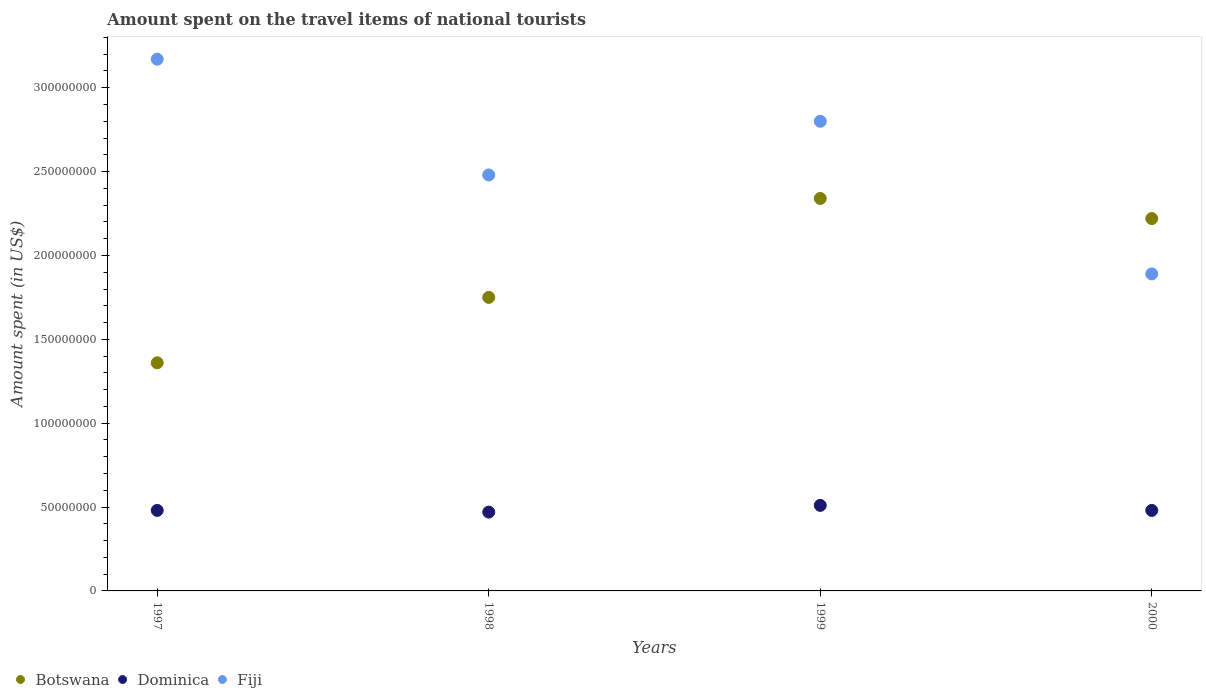Is the number of dotlines equal to the number of legend labels?
Your answer should be compact. Yes. What is the amount spent on the travel items of national tourists in Fiji in 1997?
Your answer should be very brief. 3.17e+08. Across all years, what is the maximum amount spent on the travel items of national tourists in Dominica?
Make the answer very short. 5.10e+07. Across all years, what is the minimum amount spent on the travel items of national tourists in Dominica?
Offer a very short reply. 4.70e+07. What is the total amount spent on the travel items of national tourists in Fiji in the graph?
Your answer should be compact. 1.03e+09. What is the difference between the amount spent on the travel items of national tourists in Fiji in 1998 and that in 1999?
Provide a succinct answer. -3.20e+07. What is the difference between the amount spent on the travel items of national tourists in Fiji in 1997 and the amount spent on the travel items of national tourists in Botswana in 1999?
Offer a terse response. 8.30e+07. What is the average amount spent on the travel items of national tourists in Botswana per year?
Provide a succinct answer. 1.92e+08. In the year 2000, what is the difference between the amount spent on the travel items of national tourists in Dominica and amount spent on the travel items of national tourists in Fiji?
Provide a succinct answer. -1.41e+08. What is the ratio of the amount spent on the travel items of national tourists in Botswana in 1999 to that in 2000?
Provide a short and direct response. 1.05. Is the difference between the amount spent on the travel items of national tourists in Dominica in 1998 and 1999 greater than the difference between the amount spent on the travel items of national tourists in Fiji in 1998 and 1999?
Your response must be concise. Yes. What is the difference between the highest and the lowest amount spent on the travel items of national tourists in Dominica?
Make the answer very short. 4.00e+06. Is the sum of the amount spent on the travel items of national tourists in Fiji in 1998 and 2000 greater than the maximum amount spent on the travel items of national tourists in Botswana across all years?
Offer a very short reply. Yes. Is the amount spent on the travel items of national tourists in Botswana strictly greater than the amount spent on the travel items of national tourists in Dominica over the years?
Make the answer very short. Yes. What is the difference between two consecutive major ticks on the Y-axis?
Give a very brief answer. 5.00e+07. Does the graph contain any zero values?
Keep it short and to the point. No. Does the graph contain grids?
Offer a terse response. No. How many legend labels are there?
Provide a succinct answer. 3. What is the title of the graph?
Your response must be concise. Amount spent on the travel items of national tourists. What is the label or title of the X-axis?
Your response must be concise. Years. What is the label or title of the Y-axis?
Make the answer very short. Amount spent (in US$). What is the Amount spent (in US$) of Botswana in 1997?
Provide a short and direct response. 1.36e+08. What is the Amount spent (in US$) of Dominica in 1997?
Give a very brief answer. 4.80e+07. What is the Amount spent (in US$) of Fiji in 1997?
Make the answer very short. 3.17e+08. What is the Amount spent (in US$) of Botswana in 1998?
Make the answer very short. 1.75e+08. What is the Amount spent (in US$) in Dominica in 1998?
Offer a very short reply. 4.70e+07. What is the Amount spent (in US$) of Fiji in 1998?
Ensure brevity in your answer.  2.48e+08. What is the Amount spent (in US$) of Botswana in 1999?
Ensure brevity in your answer.  2.34e+08. What is the Amount spent (in US$) in Dominica in 1999?
Your response must be concise. 5.10e+07. What is the Amount spent (in US$) in Fiji in 1999?
Ensure brevity in your answer.  2.80e+08. What is the Amount spent (in US$) in Botswana in 2000?
Your response must be concise. 2.22e+08. What is the Amount spent (in US$) in Dominica in 2000?
Give a very brief answer. 4.80e+07. What is the Amount spent (in US$) in Fiji in 2000?
Give a very brief answer. 1.89e+08. Across all years, what is the maximum Amount spent (in US$) of Botswana?
Make the answer very short. 2.34e+08. Across all years, what is the maximum Amount spent (in US$) in Dominica?
Make the answer very short. 5.10e+07. Across all years, what is the maximum Amount spent (in US$) in Fiji?
Your response must be concise. 3.17e+08. Across all years, what is the minimum Amount spent (in US$) in Botswana?
Keep it short and to the point. 1.36e+08. Across all years, what is the minimum Amount spent (in US$) in Dominica?
Offer a very short reply. 4.70e+07. Across all years, what is the minimum Amount spent (in US$) of Fiji?
Make the answer very short. 1.89e+08. What is the total Amount spent (in US$) in Botswana in the graph?
Offer a very short reply. 7.67e+08. What is the total Amount spent (in US$) of Dominica in the graph?
Offer a terse response. 1.94e+08. What is the total Amount spent (in US$) of Fiji in the graph?
Provide a short and direct response. 1.03e+09. What is the difference between the Amount spent (in US$) in Botswana in 1997 and that in 1998?
Your answer should be compact. -3.90e+07. What is the difference between the Amount spent (in US$) in Dominica in 1997 and that in 1998?
Provide a short and direct response. 1.00e+06. What is the difference between the Amount spent (in US$) in Fiji in 1997 and that in 1998?
Keep it short and to the point. 6.90e+07. What is the difference between the Amount spent (in US$) of Botswana in 1997 and that in 1999?
Provide a succinct answer. -9.80e+07. What is the difference between the Amount spent (in US$) in Dominica in 1997 and that in 1999?
Your answer should be compact. -3.00e+06. What is the difference between the Amount spent (in US$) in Fiji in 1997 and that in 1999?
Your answer should be compact. 3.70e+07. What is the difference between the Amount spent (in US$) of Botswana in 1997 and that in 2000?
Provide a short and direct response. -8.60e+07. What is the difference between the Amount spent (in US$) in Dominica in 1997 and that in 2000?
Give a very brief answer. 0. What is the difference between the Amount spent (in US$) in Fiji in 1997 and that in 2000?
Offer a terse response. 1.28e+08. What is the difference between the Amount spent (in US$) of Botswana in 1998 and that in 1999?
Your response must be concise. -5.90e+07. What is the difference between the Amount spent (in US$) in Dominica in 1998 and that in 1999?
Keep it short and to the point. -4.00e+06. What is the difference between the Amount spent (in US$) in Fiji in 1998 and that in 1999?
Your response must be concise. -3.20e+07. What is the difference between the Amount spent (in US$) in Botswana in 1998 and that in 2000?
Offer a terse response. -4.70e+07. What is the difference between the Amount spent (in US$) in Fiji in 1998 and that in 2000?
Provide a short and direct response. 5.90e+07. What is the difference between the Amount spent (in US$) of Botswana in 1999 and that in 2000?
Keep it short and to the point. 1.20e+07. What is the difference between the Amount spent (in US$) of Fiji in 1999 and that in 2000?
Make the answer very short. 9.10e+07. What is the difference between the Amount spent (in US$) of Botswana in 1997 and the Amount spent (in US$) of Dominica in 1998?
Make the answer very short. 8.90e+07. What is the difference between the Amount spent (in US$) of Botswana in 1997 and the Amount spent (in US$) of Fiji in 1998?
Offer a terse response. -1.12e+08. What is the difference between the Amount spent (in US$) in Dominica in 1997 and the Amount spent (in US$) in Fiji in 1998?
Ensure brevity in your answer.  -2.00e+08. What is the difference between the Amount spent (in US$) in Botswana in 1997 and the Amount spent (in US$) in Dominica in 1999?
Offer a very short reply. 8.50e+07. What is the difference between the Amount spent (in US$) in Botswana in 1997 and the Amount spent (in US$) in Fiji in 1999?
Make the answer very short. -1.44e+08. What is the difference between the Amount spent (in US$) in Dominica in 1997 and the Amount spent (in US$) in Fiji in 1999?
Provide a succinct answer. -2.32e+08. What is the difference between the Amount spent (in US$) of Botswana in 1997 and the Amount spent (in US$) of Dominica in 2000?
Keep it short and to the point. 8.80e+07. What is the difference between the Amount spent (in US$) of Botswana in 1997 and the Amount spent (in US$) of Fiji in 2000?
Offer a very short reply. -5.30e+07. What is the difference between the Amount spent (in US$) in Dominica in 1997 and the Amount spent (in US$) in Fiji in 2000?
Your answer should be very brief. -1.41e+08. What is the difference between the Amount spent (in US$) of Botswana in 1998 and the Amount spent (in US$) of Dominica in 1999?
Offer a terse response. 1.24e+08. What is the difference between the Amount spent (in US$) of Botswana in 1998 and the Amount spent (in US$) of Fiji in 1999?
Give a very brief answer. -1.05e+08. What is the difference between the Amount spent (in US$) of Dominica in 1998 and the Amount spent (in US$) of Fiji in 1999?
Offer a terse response. -2.33e+08. What is the difference between the Amount spent (in US$) in Botswana in 1998 and the Amount spent (in US$) in Dominica in 2000?
Ensure brevity in your answer.  1.27e+08. What is the difference between the Amount spent (in US$) in Botswana in 1998 and the Amount spent (in US$) in Fiji in 2000?
Offer a very short reply. -1.40e+07. What is the difference between the Amount spent (in US$) of Dominica in 1998 and the Amount spent (in US$) of Fiji in 2000?
Provide a short and direct response. -1.42e+08. What is the difference between the Amount spent (in US$) of Botswana in 1999 and the Amount spent (in US$) of Dominica in 2000?
Offer a very short reply. 1.86e+08. What is the difference between the Amount spent (in US$) in Botswana in 1999 and the Amount spent (in US$) in Fiji in 2000?
Offer a terse response. 4.50e+07. What is the difference between the Amount spent (in US$) in Dominica in 1999 and the Amount spent (in US$) in Fiji in 2000?
Make the answer very short. -1.38e+08. What is the average Amount spent (in US$) of Botswana per year?
Offer a terse response. 1.92e+08. What is the average Amount spent (in US$) of Dominica per year?
Offer a terse response. 4.85e+07. What is the average Amount spent (in US$) of Fiji per year?
Your answer should be very brief. 2.58e+08. In the year 1997, what is the difference between the Amount spent (in US$) of Botswana and Amount spent (in US$) of Dominica?
Your answer should be very brief. 8.80e+07. In the year 1997, what is the difference between the Amount spent (in US$) in Botswana and Amount spent (in US$) in Fiji?
Offer a terse response. -1.81e+08. In the year 1997, what is the difference between the Amount spent (in US$) in Dominica and Amount spent (in US$) in Fiji?
Offer a terse response. -2.69e+08. In the year 1998, what is the difference between the Amount spent (in US$) of Botswana and Amount spent (in US$) of Dominica?
Your response must be concise. 1.28e+08. In the year 1998, what is the difference between the Amount spent (in US$) of Botswana and Amount spent (in US$) of Fiji?
Provide a succinct answer. -7.30e+07. In the year 1998, what is the difference between the Amount spent (in US$) of Dominica and Amount spent (in US$) of Fiji?
Keep it short and to the point. -2.01e+08. In the year 1999, what is the difference between the Amount spent (in US$) of Botswana and Amount spent (in US$) of Dominica?
Offer a very short reply. 1.83e+08. In the year 1999, what is the difference between the Amount spent (in US$) in Botswana and Amount spent (in US$) in Fiji?
Make the answer very short. -4.60e+07. In the year 1999, what is the difference between the Amount spent (in US$) of Dominica and Amount spent (in US$) of Fiji?
Your answer should be very brief. -2.29e+08. In the year 2000, what is the difference between the Amount spent (in US$) in Botswana and Amount spent (in US$) in Dominica?
Keep it short and to the point. 1.74e+08. In the year 2000, what is the difference between the Amount spent (in US$) of Botswana and Amount spent (in US$) of Fiji?
Your answer should be compact. 3.30e+07. In the year 2000, what is the difference between the Amount spent (in US$) of Dominica and Amount spent (in US$) of Fiji?
Keep it short and to the point. -1.41e+08. What is the ratio of the Amount spent (in US$) of Botswana in 1997 to that in 1998?
Provide a succinct answer. 0.78. What is the ratio of the Amount spent (in US$) in Dominica in 1997 to that in 1998?
Make the answer very short. 1.02. What is the ratio of the Amount spent (in US$) of Fiji in 1997 to that in 1998?
Ensure brevity in your answer.  1.28. What is the ratio of the Amount spent (in US$) in Botswana in 1997 to that in 1999?
Offer a very short reply. 0.58. What is the ratio of the Amount spent (in US$) of Dominica in 1997 to that in 1999?
Give a very brief answer. 0.94. What is the ratio of the Amount spent (in US$) in Fiji in 1997 to that in 1999?
Your answer should be compact. 1.13. What is the ratio of the Amount spent (in US$) of Botswana in 1997 to that in 2000?
Your response must be concise. 0.61. What is the ratio of the Amount spent (in US$) of Dominica in 1997 to that in 2000?
Your answer should be very brief. 1. What is the ratio of the Amount spent (in US$) of Fiji in 1997 to that in 2000?
Give a very brief answer. 1.68. What is the ratio of the Amount spent (in US$) of Botswana in 1998 to that in 1999?
Provide a succinct answer. 0.75. What is the ratio of the Amount spent (in US$) in Dominica in 1998 to that in 1999?
Offer a very short reply. 0.92. What is the ratio of the Amount spent (in US$) of Fiji in 1998 to that in 1999?
Offer a very short reply. 0.89. What is the ratio of the Amount spent (in US$) in Botswana in 1998 to that in 2000?
Ensure brevity in your answer.  0.79. What is the ratio of the Amount spent (in US$) of Dominica in 1998 to that in 2000?
Provide a succinct answer. 0.98. What is the ratio of the Amount spent (in US$) in Fiji in 1998 to that in 2000?
Give a very brief answer. 1.31. What is the ratio of the Amount spent (in US$) in Botswana in 1999 to that in 2000?
Offer a very short reply. 1.05. What is the ratio of the Amount spent (in US$) in Fiji in 1999 to that in 2000?
Keep it short and to the point. 1.48. What is the difference between the highest and the second highest Amount spent (in US$) in Botswana?
Provide a succinct answer. 1.20e+07. What is the difference between the highest and the second highest Amount spent (in US$) of Fiji?
Keep it short and to the point. 3.70e+07. What is the difference between the highest and the lowest Amount spent (in US$) of Botswana?
Give a very brief answer. 9.80e+07. What is the difference between the highest and the lowest Amount spent (in US$) of Fiji?
Your answer should be very brief. 1.28e+08. 